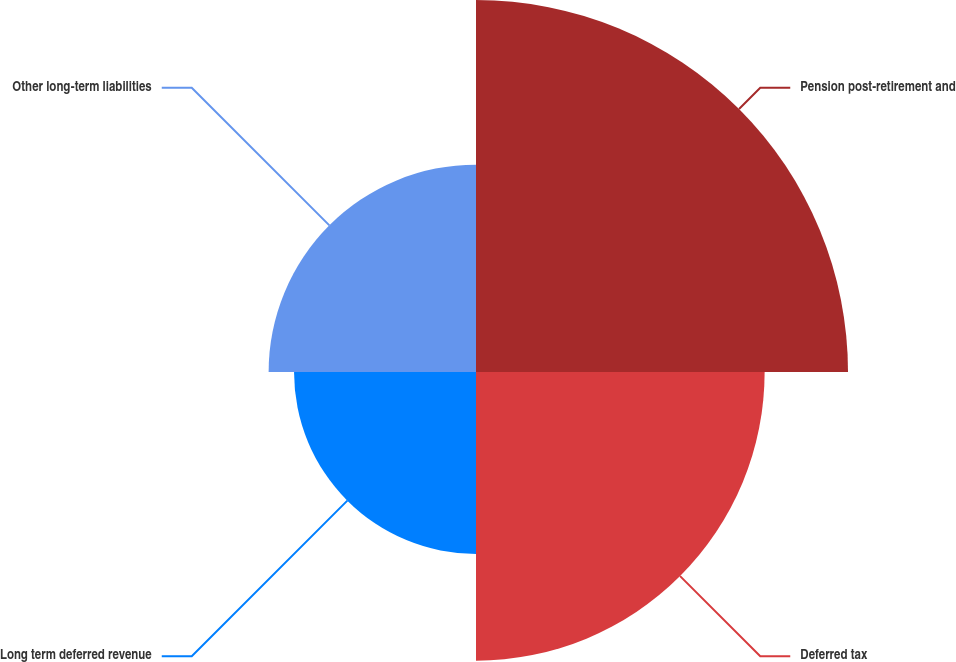Convert chart to OTSL. <chart><loc_0><loc_0><loc_500><loc_500><pie_chart><fcel>Pension post-retirement and<fcel>Deferred tax<fcel>Long term deferred revenue<fcel>Other long-term liabilities<nl><fcel>35.43%<fcel>27.49%<fcel>17.33%<fcel>19.75%<nl></chart> 